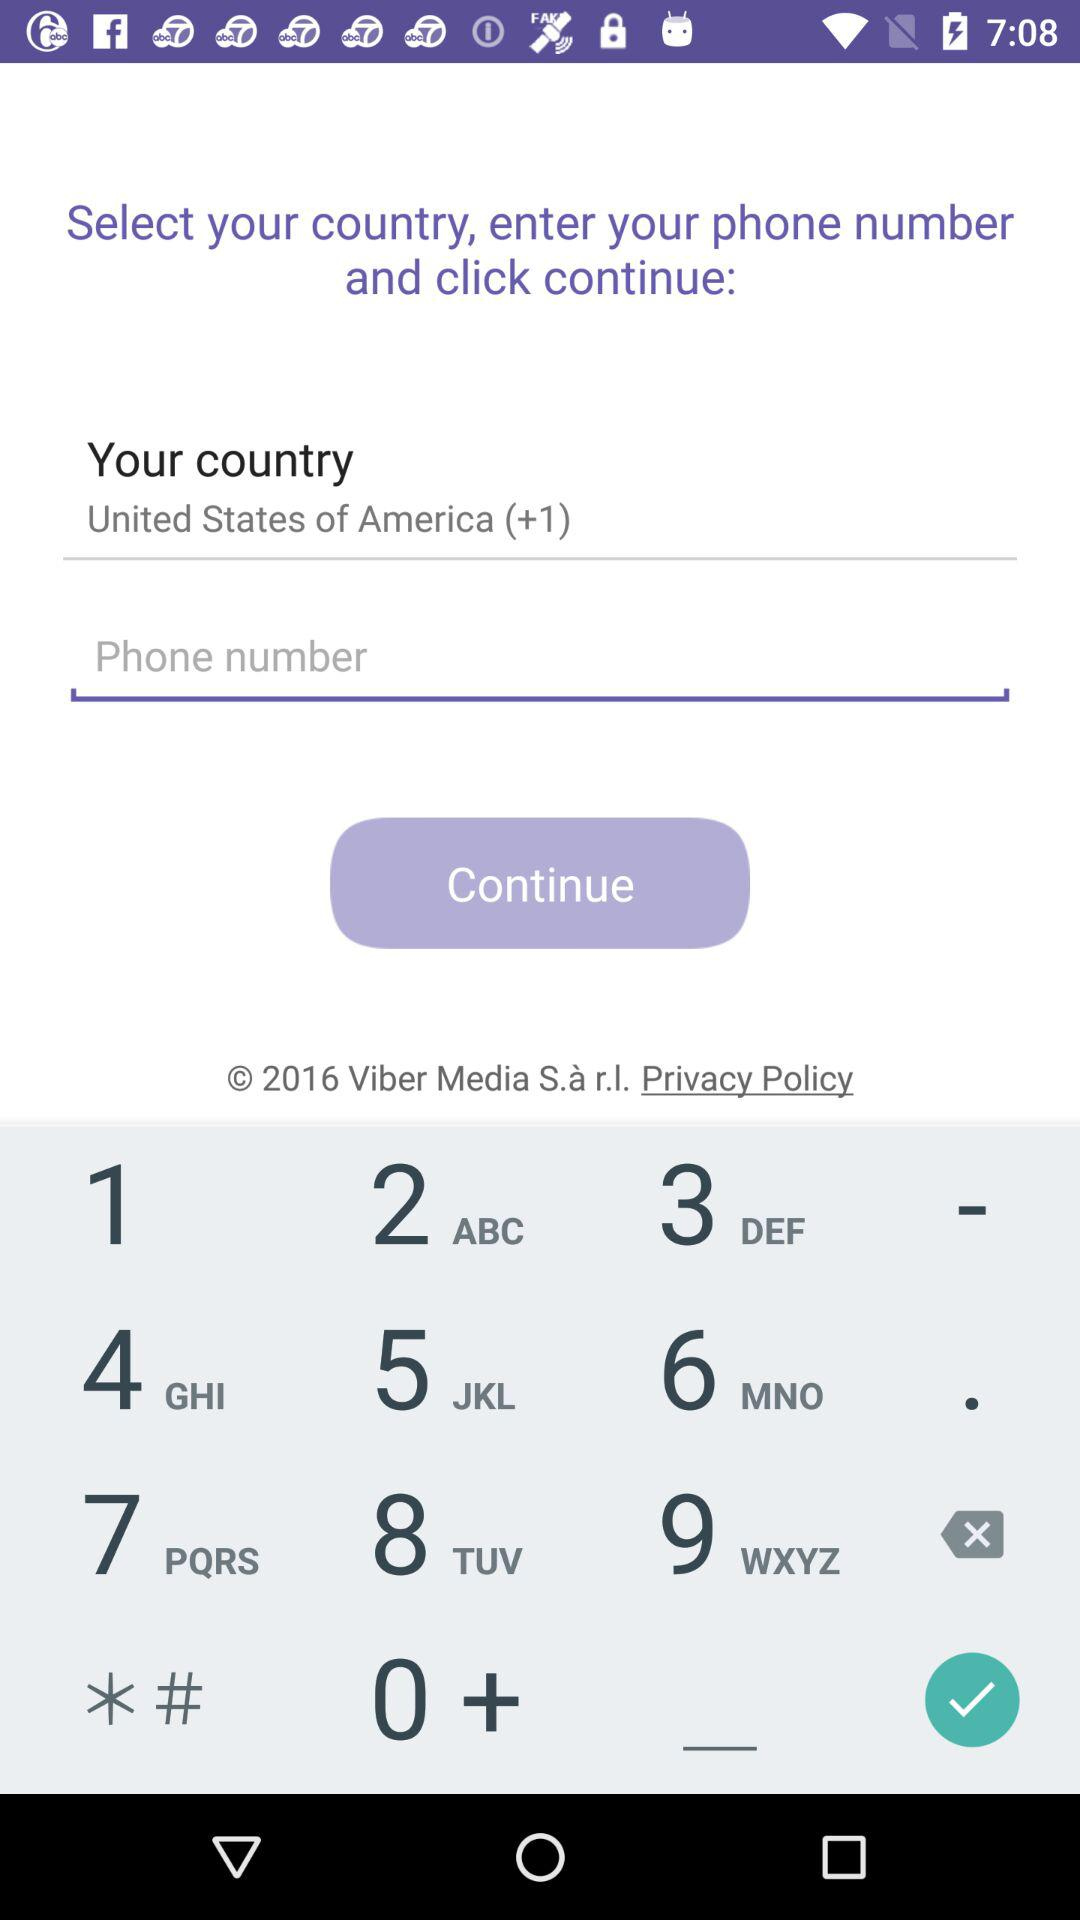Where do we need to click after selecting a country and entering a phone number? We need to click on "continue". 